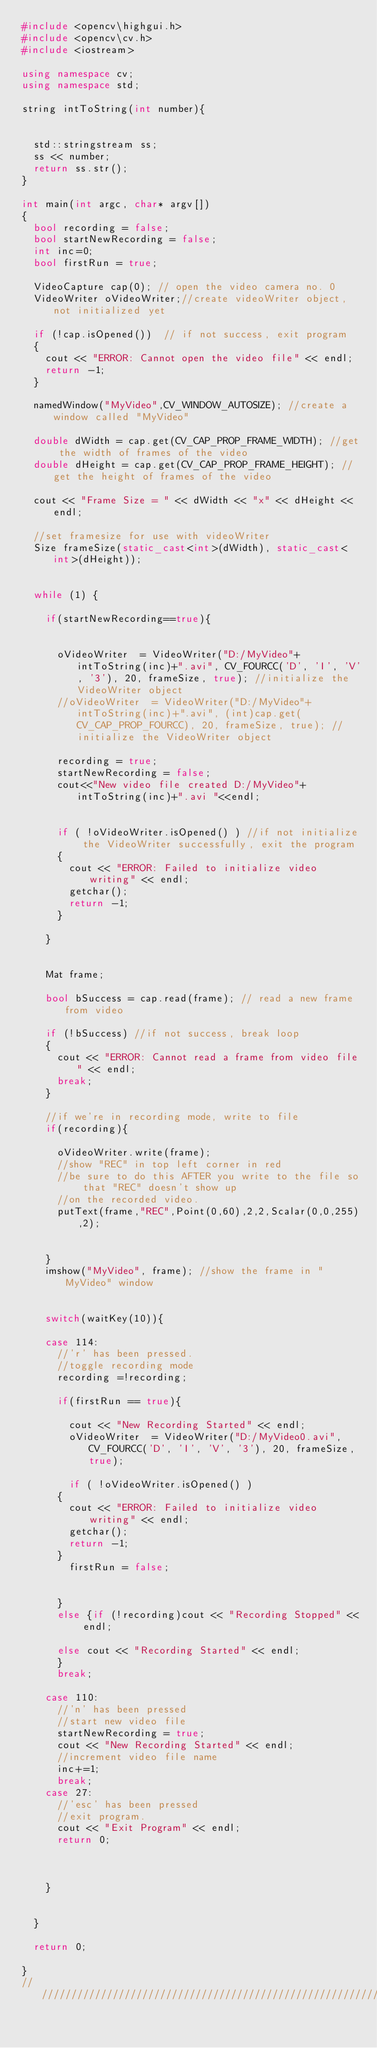<code> <loc_0><loc_0><loc_500><loc_500><_C++_>#include <opencv\highgui.h>
#include <opencv\cv.h>
#include <iostream>

using namespace cv;
using namespace std;

string intToString(int number){


	std::stringstream ss;
	ss << number;
	return ss.str();
}

int main(int argc, char* argv[])
{
	bool recording = false;
	bool startNewRecording = false;
	int inc=0;
	bool firstRun = true;

	VideoCapture cap(0); // open the video camera no. 0
	VideoWriter oVideoWriter;//create videoWriter object, not initialized yet

	if (!cap.isOpened())  // if not success, exit program
	{
		cout << "ERROR: Cannot open the video file" << endl;
		return -1;
	}

	namedWindow("MyVideo",CV_WINDOW_AUTOSIZE); //create a window called "MyVideo"

	double dWidth = cap.get(CV_CAP_PROP_FRAME_WIDTH); //get the width of frames of the video
	double dHeight = cap.get(CV_CAP_PROP_FRAME_HEIGHT); //get the height of frames of the video

	cout << "Frame Size = " << dWidth << "x" << dHeight << endl;

	//set framesize for use with videoWriter
	Size frameSize(static_cast<int>(dWidth), static_cast<int>(dHeight));


	while (1) {

		if(startNewRecording==true){

			
			oVideoWriter  = VideoWriter("D:/MyVideo"+intToString(inc)+".avi", CV_FOURCC('D', 'I', 'V', '3'), 20, frameSize, true); //initialize the VideoWriter object 
			//oVideoWriter  = VideoWriter("D:/MyVideo"+intToString(inc)+".avi", (int)cap.get(CV_CAP_PROP_FOURCC), 20, frameSize, true); //initialize the VideoWriter object 

			recording = true;
			startNewRecording = false;
			cout<<"New video file created D:/MyVideo"+intToString(inc)+".avi "<<endl;


			if ( !oVideoWriter.isOpened() ) //if not initialize the VideoWriter successfully, exit the program
			{
				cout << "ERROR: Failed to initialize video writing" << endl;
				getchar();
				return -1;
			}

		}


		Mat frame;

		bool bSuccess = cap.read(frame); // read a new frame from video

		if (!bSuccess) //if not success, break loop
		{
			cout << "ERROR: Cannot read a frame from video file" << endl;
			break;
		}

		//if we're in recording mode, write to file
		if(recording){

			oVideoWriter.write(frame);
			//show "REC" in top left corner in red
			//be sure to do this AFTER you write to the file so that "REC" doesn't show up
			//on the recorded video.
			putText(frame,"REC",Point(0,60),2,2,Scalar(0,0,255),2);


		}
		imshow("MyVideo", frame); //show the frame in "MyVideo" window


		switch(waitKey(10)){

		case 114:
			//'r' has been pressed.
			//toggle recording mode
			recording =!recording;

			if(firstRun == true){

				cout << "New Recording Started" << endl;
				oVideoWriter  = VideoWriter("D:/MyVideo0.avi", CV_FOURCC('D', 'I', 'V', '3'), 20, frameSize, true);

				if ( !oVideoWriter.isOpened() ) 
			{
				cout << "ERROR: Failed to initialize video writing" << endl;
				getchar();
				return -1;
			}
				firstRun = false;


			}
			else {if (!recording)cout << "Recording Stopped" << endl;

			else cout << "Recording Started" << endl;
			}
			break;

		case 110:
			//'n' has been pressed
			//start new video file
			startNewRecording = true;
			cout << "New Recording Started" << endl;
			//increment video file name
			inc+=1;
			break; 
		case 27:
			//'esc' has been pressed
			//exit program.
			cout << "Exit Program" << endl;
			return 0;



		}


	}

	return 0;

}
////////////////////////////////////////////////////////////////////////////////////////////</code> 